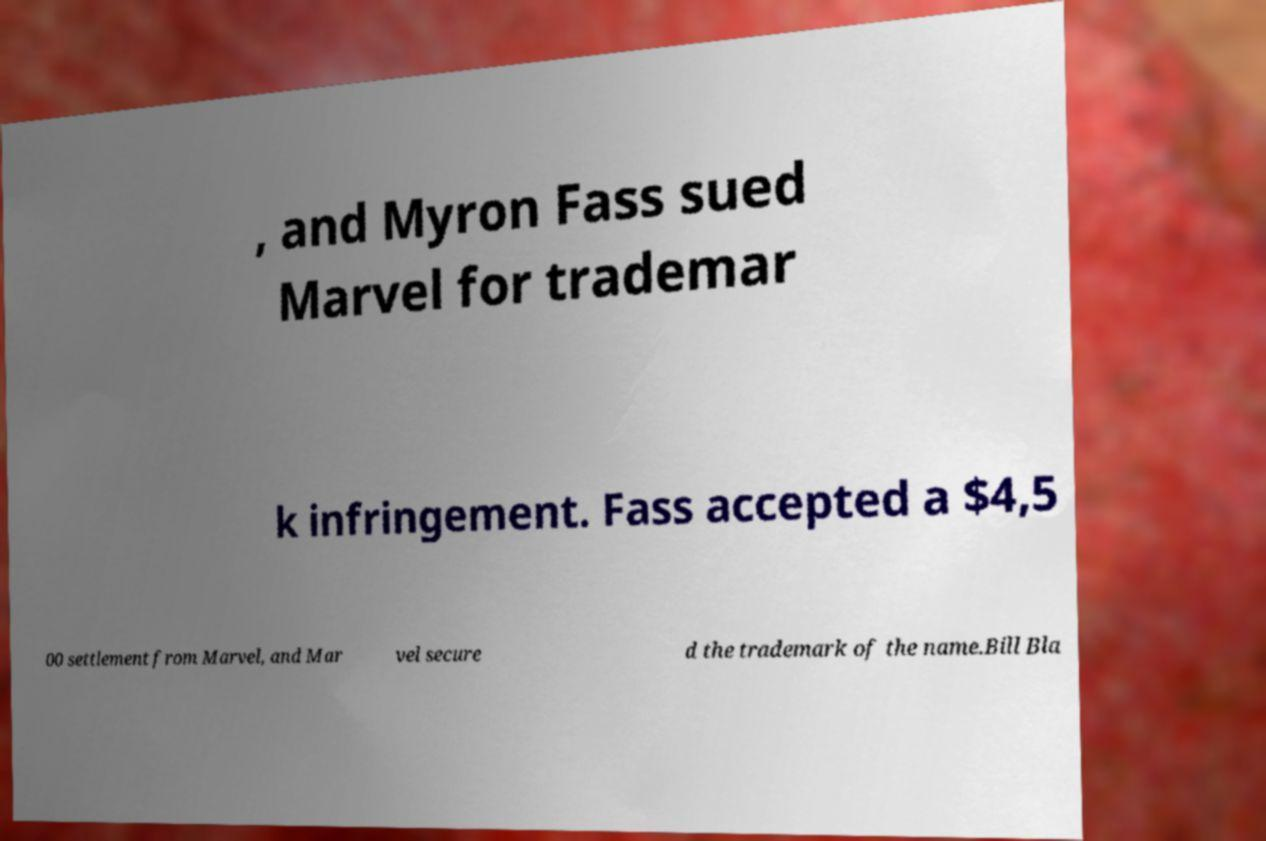Can you read and provide the text displayed in the image?This photo seems to have some interesting text. Can you extract and type it out for me? , and Myron Fass sued Marvel for trademar k infringement. Fass accepted a $4,5 00 settlement from Marvel, and Mar vel secure d the trademark of the name.Bill Bla 